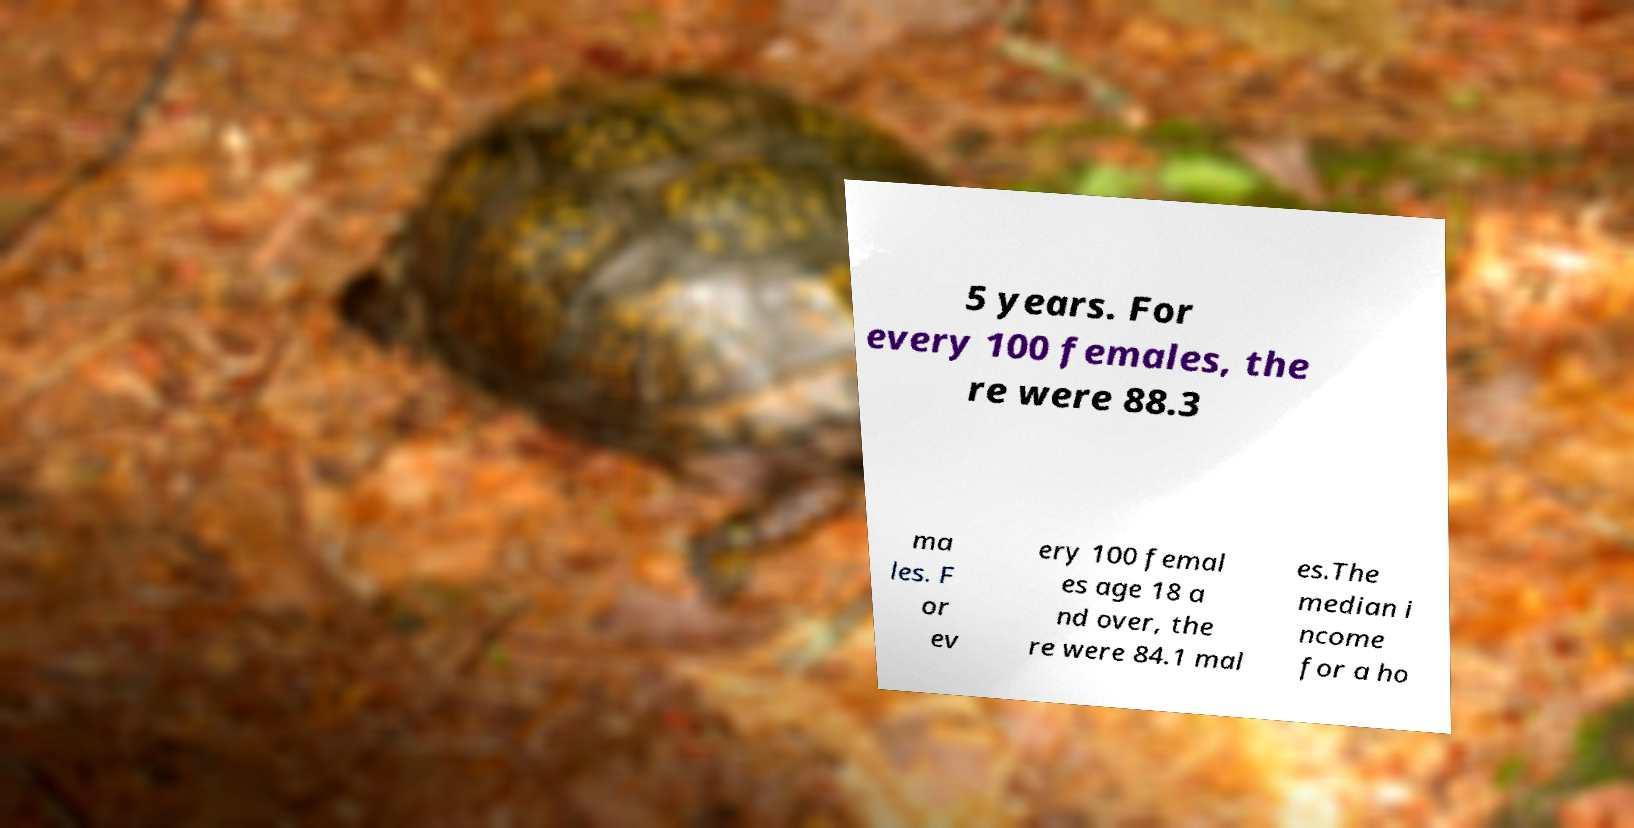For documentation purposes, I need the text within this image transcribed. Could you provide that? 5 years. For every 100 females, the re were 88.3 ma les. F or ev ery 100 femal es age 18 a nd over, the re were 84.1 mal es.The median i ncome for a ho 